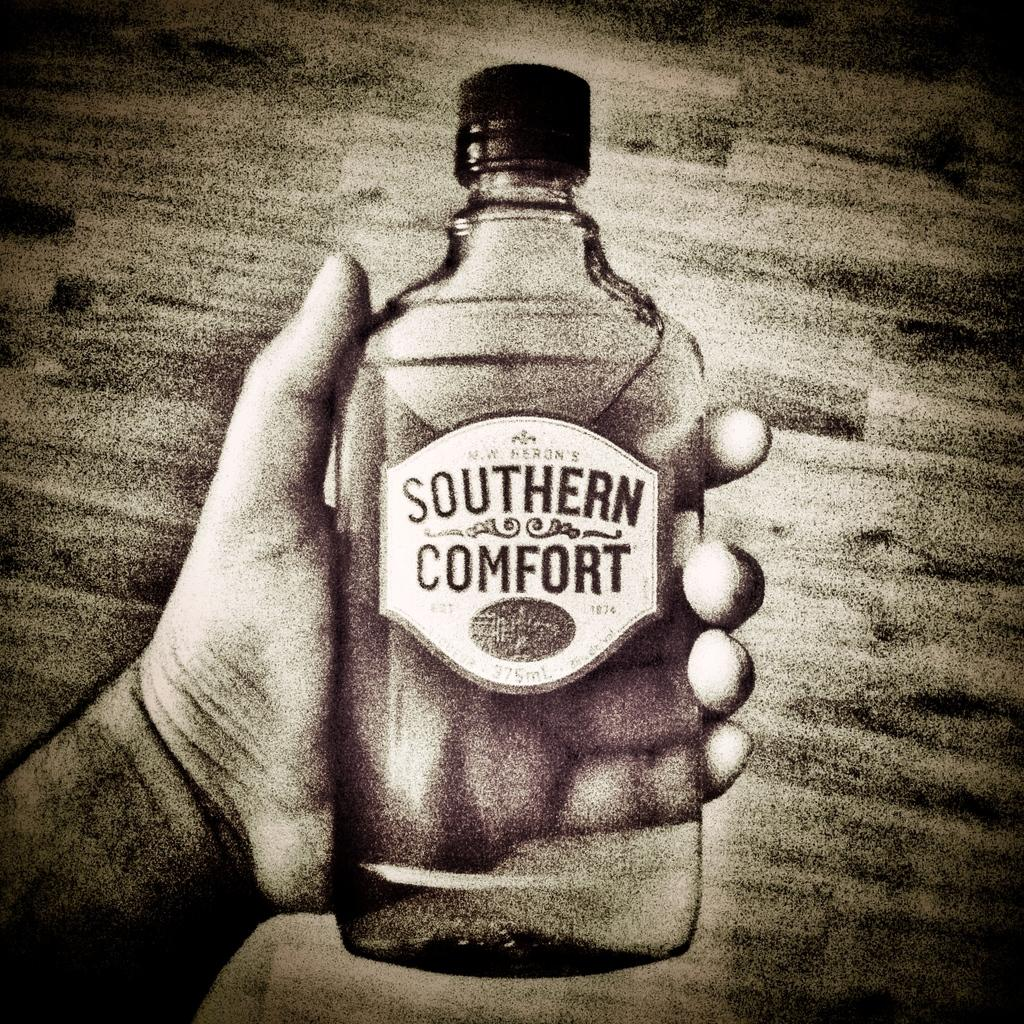What object is being held by a person in the image? There is a glass bottle in the image, and a person is holding it in their hand. Can you describe the appearance of the glass bottle? The provided facts do not include a description of the appearance of the glass bottle. How does the basketball affect the glass bottle during the earthquake in the image? There is no basketball or earthquake present in the image; it only features a person holding a glass bottle. 